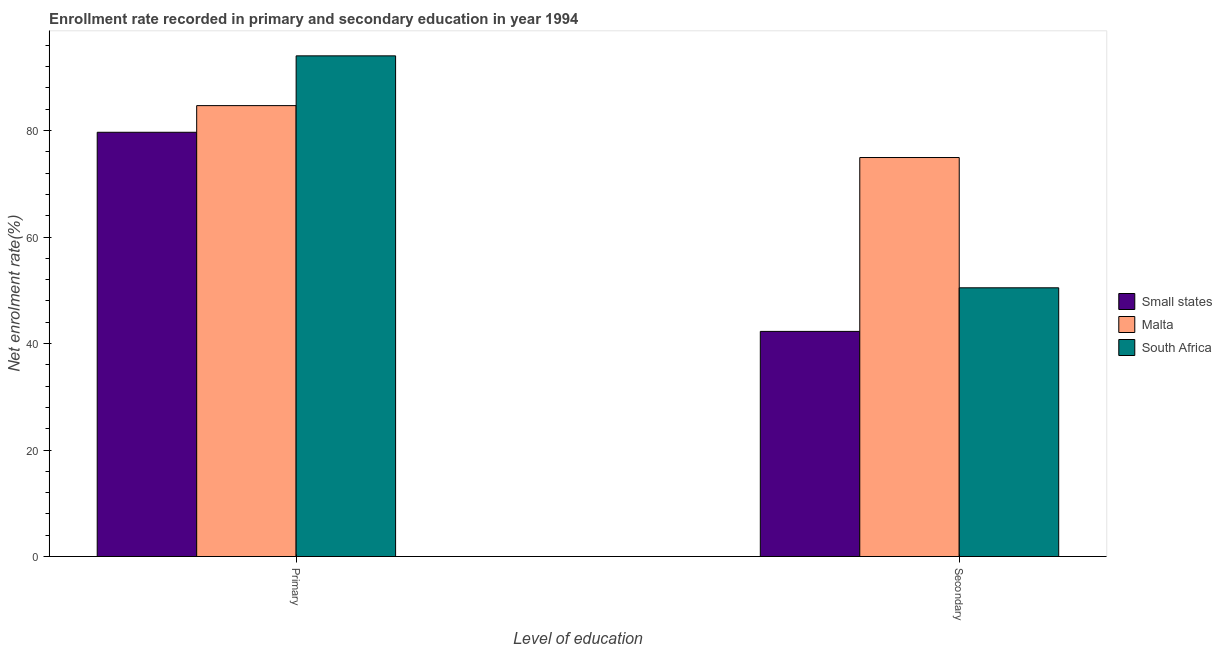How many different coloured bars are there?
Ensure brevity in your answer.  3. How many groups of bars are there?
Give a very brief answer. 2. How many bars are there on the 2nd tick from the left?
Your answer should be compact. 3. What is the label of the 2nd group of bars from the left?
Give a very brief answer. Secondary. What is the enrollment rate in secondary education in South Africa?
Give a very brief answer. 50.47. Across all countries, what is the maximum enrollment rate in secondary education?
Provide a succinct answer. 74.94. Across all countries, what is the minimum enrollment rate in secondary education?
Ensure brevity in your answer.  42.28. In which country was the enrollment rate in secondary education maximum?
Provide a short and direct response. Malta. In which country was the enrollment rate in primary education minimum?
Your response must be concise. Small states. What is the total enrollment rate in secondary education in the graph?
Provide a succinct answer. 167.69. What is the difference between the enrollment rate in primary education in Malta and that in Small states?
Offer a very short reply. 5. What is the difference between the enrollment rate in secondary education in Malta and the enrollment rate in primary education in South Africa?
Provide a short and direct response. -19.09. What is the average enrollment rate in secondary education per country?
Provide a succinct answer. 55.9. What is the difference between the enrollment rate in primary education and enrollment rate in secondary education in South Africa?
Make the answer very short. 43.56. In how many countries, is the enrollment rate in primary education greater than 12 %?
Provide a short and direct response. 3. What is the ratio of the enrollment rate in secondary education in Malta to that in South Africa?
Provide a succinct answer. 1.48. Is the enrollment rate in primary education in Small states less than that in South Africa?
Offer a very short reply. Yes. What does the 3rd bar from the left in Primary represents?
Make the answer very short. South Africa. What does the 2nd bar from the right in Primary represents?
Provide a short and direct response. Malta. How many bars are there?
Provide a succinct answer. 6. Are all the bars in the graph horizontal?
Offer a terse response. No. How many countries are there in the graph?
Your response must be concise. 3. Are the values on the major ticks of Y-axis written in scientific E-notation?
Your answer should be very brief. No. Does the graph contain grids?
Give a very brief answer. No. Where does the legend appear in the graph?
Your answer should be compact. Center right. How many legend labels are there?
Offer a terse response. 3. What is the title of the graph?
Provide a succinct answer. Enrollment rate recorded in primary and secondary education in year 1994. What is the label or title of the X-axis?
Provide a short and direct response. Level of education. What is the label or title of the Y-axis?
Your response must be concise. Net enrolment rate(%). What is the Net enrolment rate(%) in Small states in Primary?
Your answer should be very brief. 79.68. What is the Net enrolment rate(%) of Malta in Primary?
Your response must be concise. 84.69. What is the Net enrolment rate(%) of South Africa in Primary?
Your response must be concise. 94.03. What is the Net enrolment rate(%) in Small states in Secondary?
Your answer should be very brief. 42.28. What is the Net enrolment rate(%) of Malta in Secondary?
Ensure brevity in your answer.  74.94. What is the Net enrolment rate(%) in South Africa in Secondary?
Provide a short and direct response. 50.47. Across all Level of education, what is the maximum Net enrolment rate(%) of Small states?
Keep it short and to the point. 79.68. Across all Level of education, what is the maximum Net enrolment rate(%) of Malta?
Provide a short and direct response. 84.69. Across all Level of education, what is the maximum Net enrolment rate(%) in South Africa?
Your answer should be very brief. 94.03. Across all Level of education, what is the minimum Net enrolment rate(%) in Small states?
Offer a very short reply. 42.28. Across all Level of education, what is the minimum Net enrolment rate(%) of Malta?
Ensure brevity in your answer.  74.94. Across all Level of education, what is the minimum Net enrolment rate(%) of South Africa?
Provide a short and direct response. 50.47. What is the total Net enrolment rate(%) of Small states in the graph?
Your answer should be compact. 121.96. What is the total Net enrolment rate(%) in Malta in the graph?
Offer a very short reply. 159.63. What is the total Net enrolment rate(%) of South Africa in the graph?
Your answer should be compact. 144.5. What is the difference between the Net enrolment rate(%) in Small states in Primary and that in Secondary?
Keep it short and to the point. 37.4. What is the difference between the Net enrolment rate(%) of Malta in Primary and that in Secondary?
Your response must be concise. 9.75. What is the difference between the Net enrolment rate(%) in South Africa in Primary and that in Secondary?
Offer a very short reply. 43.56. What is the difference between the Net enrolment rate(%) of Small states in Primary and the Net enrolment rate(%) of Malta in Secondary?
Provide a succinct answer. 4.74. What is the difference between the Net enrolment rate(%) of Small states in Primary and the Net enrolment rate(%) of South Africa in Secondary?
Provide a succinct answer. 29.21. What is the difference between the Net enrolment rate(%) of Malta in Primary and the Net enrolment rate(%) of South Africa in Secondary?
Offer a terse response. 34.22. What is the average Net enrolment rate(%) of Small states per Level of education?
Make the answer very short. 60.98. What is the average Net enrolment rate(%) of Malta per Level of education?
Provide a succinct answer. 79.81. What is the average Net enrolment rate(%) of South Africa per Level of education?
Give a very brief answer. 72.25. What is the difference between the Net enrolment rate(%) in Small states and Net enrolment rate(%) in Malta in Primary?
Ensure brevity in your answer.  -5. What is the difference between the Net enrolment rate(%) in Small states and Net enrolment rate(%) in South Africa in Primary?
Your answer should be very brief. -14.35. What is the difference between the Net enrolment rate(%) in Malta and Net enrolment rate(%) in South Africa in Primary?
Your response must be concise. -9.35. What is the difference between the Net enrolment rate(%) of Small states and Net enrolment rate(%) of Malta in Secondary?
Make the answer very short. -32.66. What is the difference between the Net enrolment rate(%) in Small states and Net enrolment rate(%) in South Africa in Secondary?
Ensure brevity in your answer.  -8.19. What is the difference between the Net enrolment rate(%) in Malta and Net enrolment rate(%) in South Africa in Secondary?
Give a very brief answer. 24.47. What is the ratio of the Net enrolment rate(%) of Small states in Primary to that in Secondary?
Provide a short and direct response. 1.88. What is the ratio of the Net enrolment rate(%) of Malta in Primary to that in Secondary?
Provide a short and direct response. 1.13. What is the ratio of the Net enrolment rate(%) of South Africa in Primary to that in Secondary?
Your answer should be compact. 1.86. What is the difference between the highest and the second highest Net enrolment rate(%) in Small states?
Provide a short and direct response. 37.4. What is the difference between the highest and the second highest Net enrolment rate(%) of Malta?
Ensure brevity in your answer.  9.75. What is the difference between the highest and the second highest Net enrolment rate(%) of South Africa?
Keep it short and to the point. 43.56. What is the difference between the highest and the lowest Net enrolment rate(%) in Small states?
Offer a very short reply. 37.4. What is the difference between the highest and the lowest Net enrolment rate(%) of Malta?
Provide a succinct answer. 9.75. What is the difference between the highest and the lowest Net enrolment rate(%) in South Africa?
Ensure brevity in your answer.  43.56. 